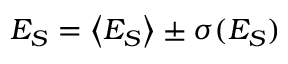<formula> <loc_0><loc_0><loc_500><loc_500>E _ { S } = \left < E _ { S } \right > \pm \sigma ( E _ { S } )</formula> 